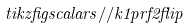Convert formula to latex. <formula><loc_0><loc_0><loc_500><loc_500>\ t i k z f i g { s c a l a r s / / k 1 p r f 2 f l i p }</formula> 